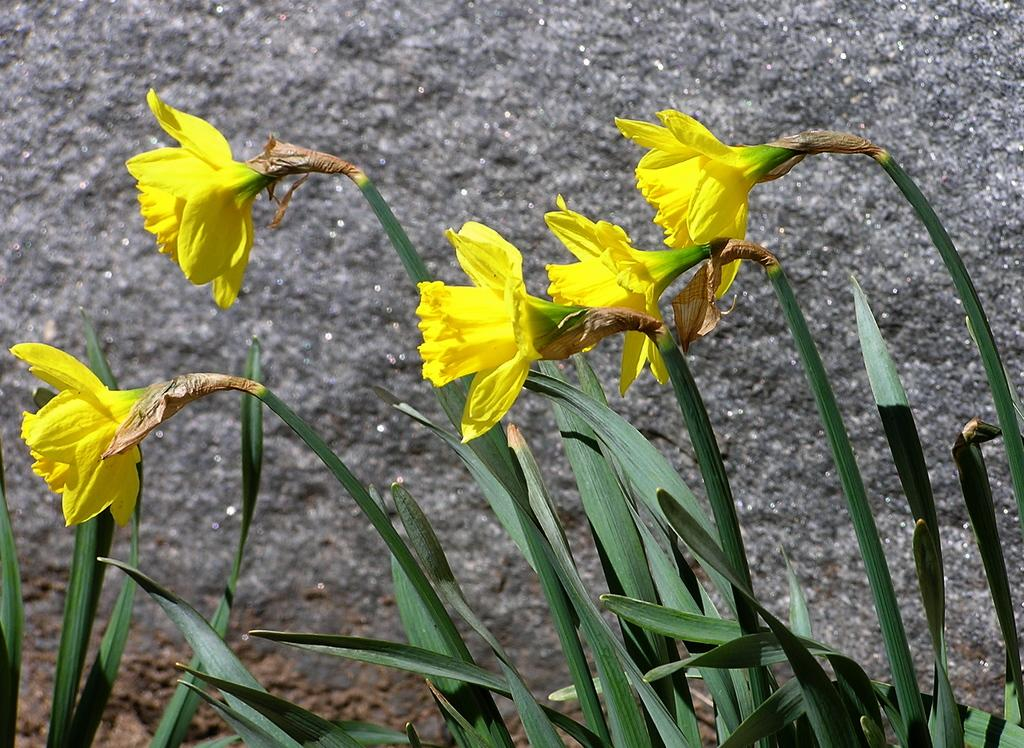What type of vegetation is present at the bottom of the image? There are plants at the bottom of the image. What color are the flowers in the middle of the image? The flowers in the middle of the image are yellow. What type of bean is growing next to the yellow flowers in the image? There is no bean present in the image; it only features plants and yellow flowers. What scene is depicted in the background of the image? The provided facts do not mention a background scene, so it cannot be determined from the image. 